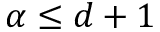Convert formula to latex. <formula><loc_0><loc_0><loc_500><loc_500>\alpha \leq d + 1</formula> 